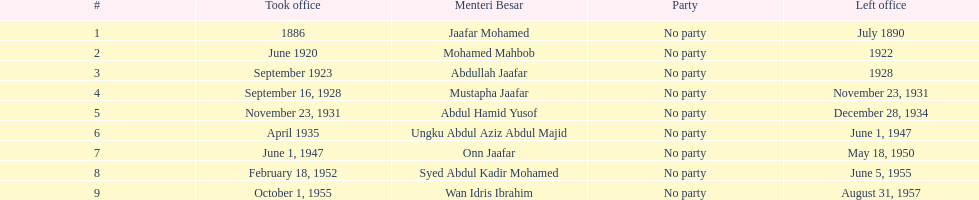Who took office after onn jaafar? Syed Abdul Kadir Mohamed. 